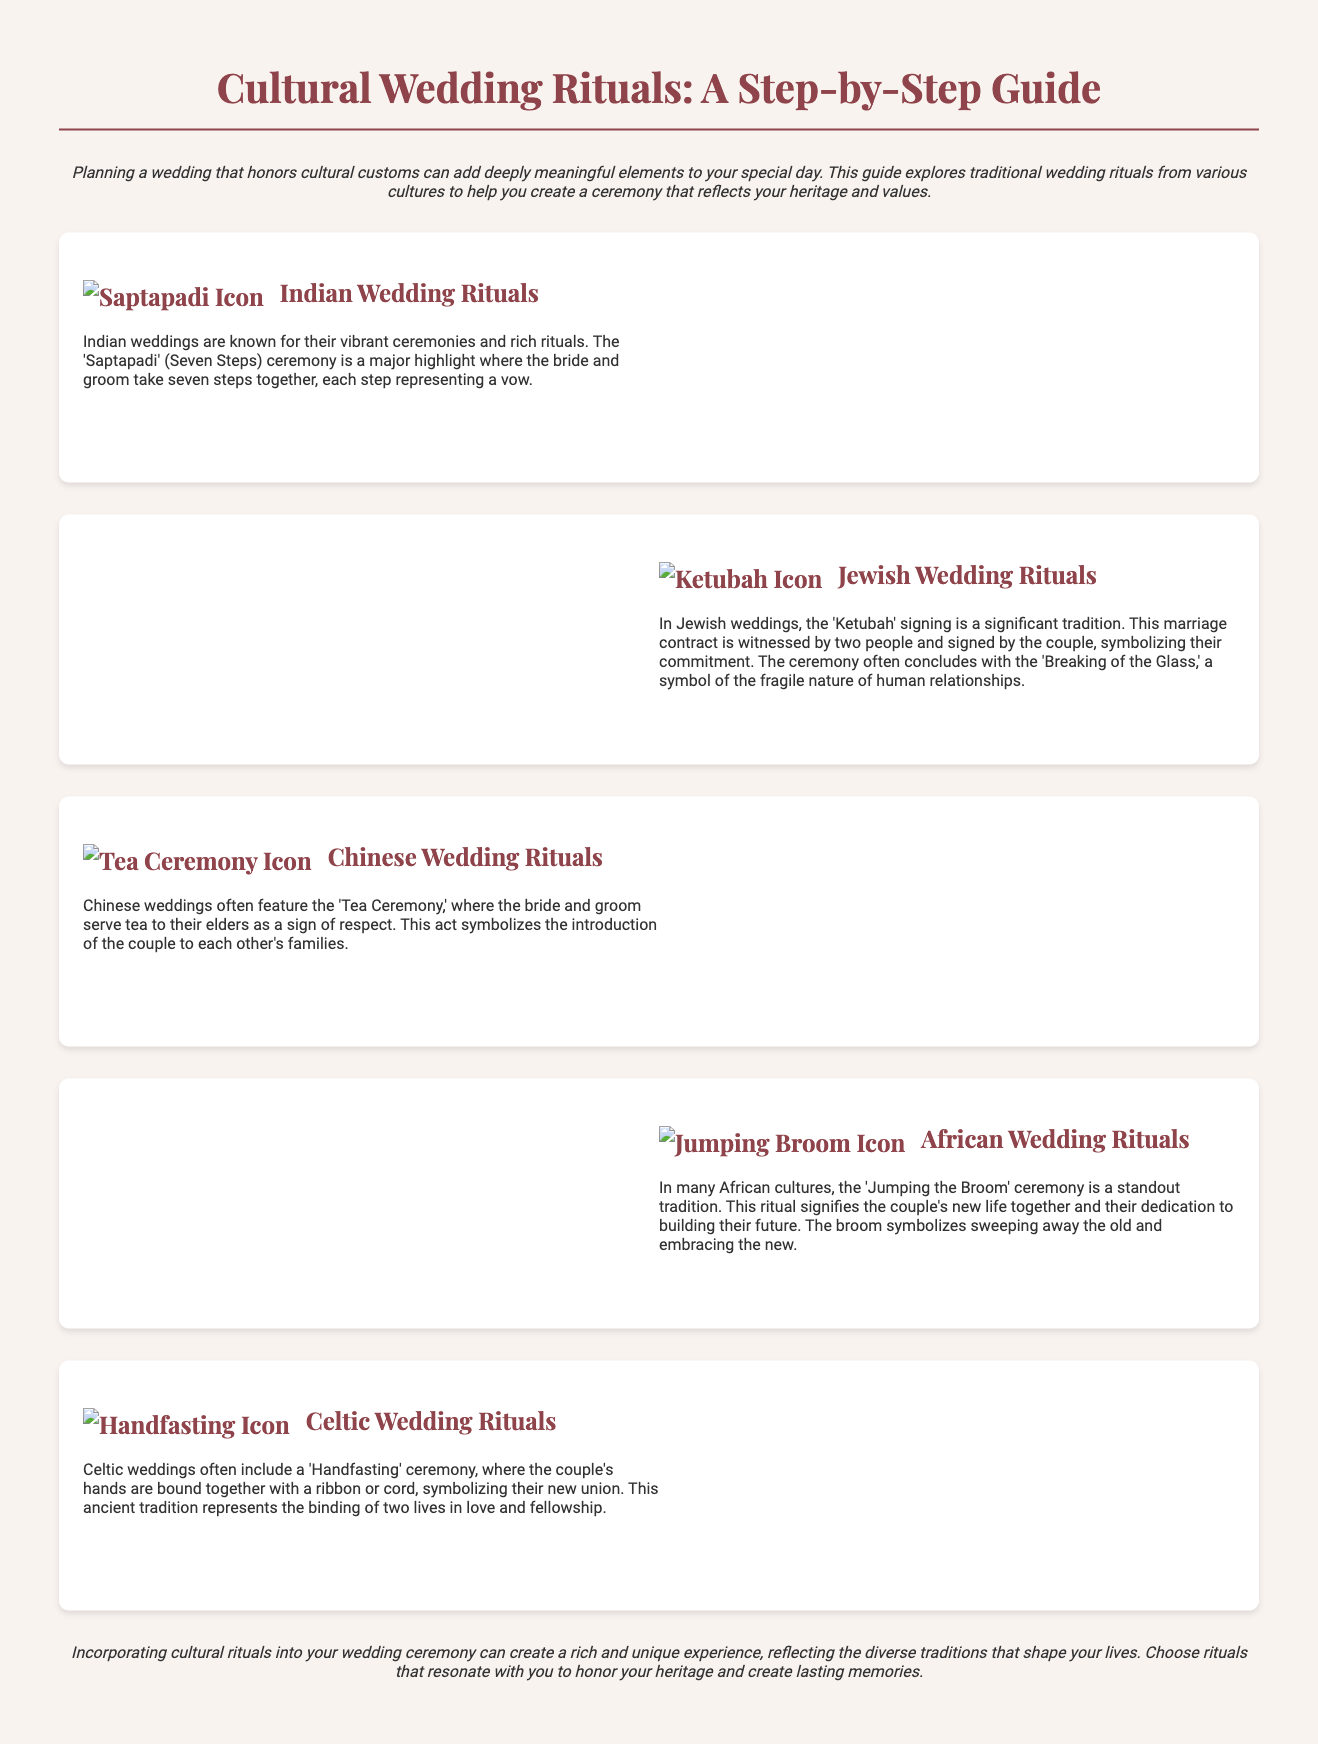What is the title of the guide? The title of the guide is presented prominently at the beginning of the document.
Answer: Cultural Wedding Rituals: A Step-by-Step Guide What is the first cultural ritual mentioned? The document highlights various cultural rituals, starting with the first listed in the sections.
Answer: Indian Wedding Rituals What is the name of the ceremony where the couple takes seven steps? The guide explains this particular ceremony as part of Indian wedding traditions.
Answer: Saptapadi Which cultural wedding ritual involves serving tea to elders? The description indicates a specific act in Chinese weddings that reflects respect for family.
Answer: Tea Ceremony What does "Jumping the Broom" symbolize? The document states that this ceremony signifies a specific aspect of the couple's new life together.
Answer: Sweeping away the old How is the couple bound during the Handfasting ceremony? The guide details how this ritual is performed during Celtic weddings.
Answer: With a ribbon or cord What symbol marks the conclusion of a Jewish wedding ceremony? The document mentions a notable act at the end of Jewish wedding rituals.
Answer: Breaking of the Glass How many steps are taken in the Saptapadi ceremony? The guide specifies the number of steps involved in this significant Indian ritual.
Answer: Seven Steps 